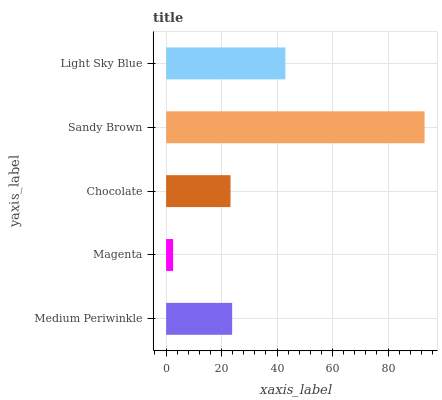Is Magenta the minimum?
Answer yes or no. Yes. Is Sandy Brown the maximum?
Answer yes or no. Yes. Is Chocolate the minimum?
Answer yes or no. No. Is Chocolate the maximum?
Answer yes or no. No. Is Chocolate greater than Magenta?
Answer yes or no. Yes. Is Magenta less than Chocolate?
Answer yes or no. Yes. Is Magenta greater than Chocolate?
Answer yes or no. No. Is Chocolate less than Magenta?
Answer yes or no. No. Is Medium Periwinkle the high median?
Answer yes or no. Yes. Is Medium Periwinkle the low median?
Answer yes or no. Yes. Is Sandy Brown the high median?
Answer yes or no. No. Is Magenta the low median?
Answer yes or no. No. 